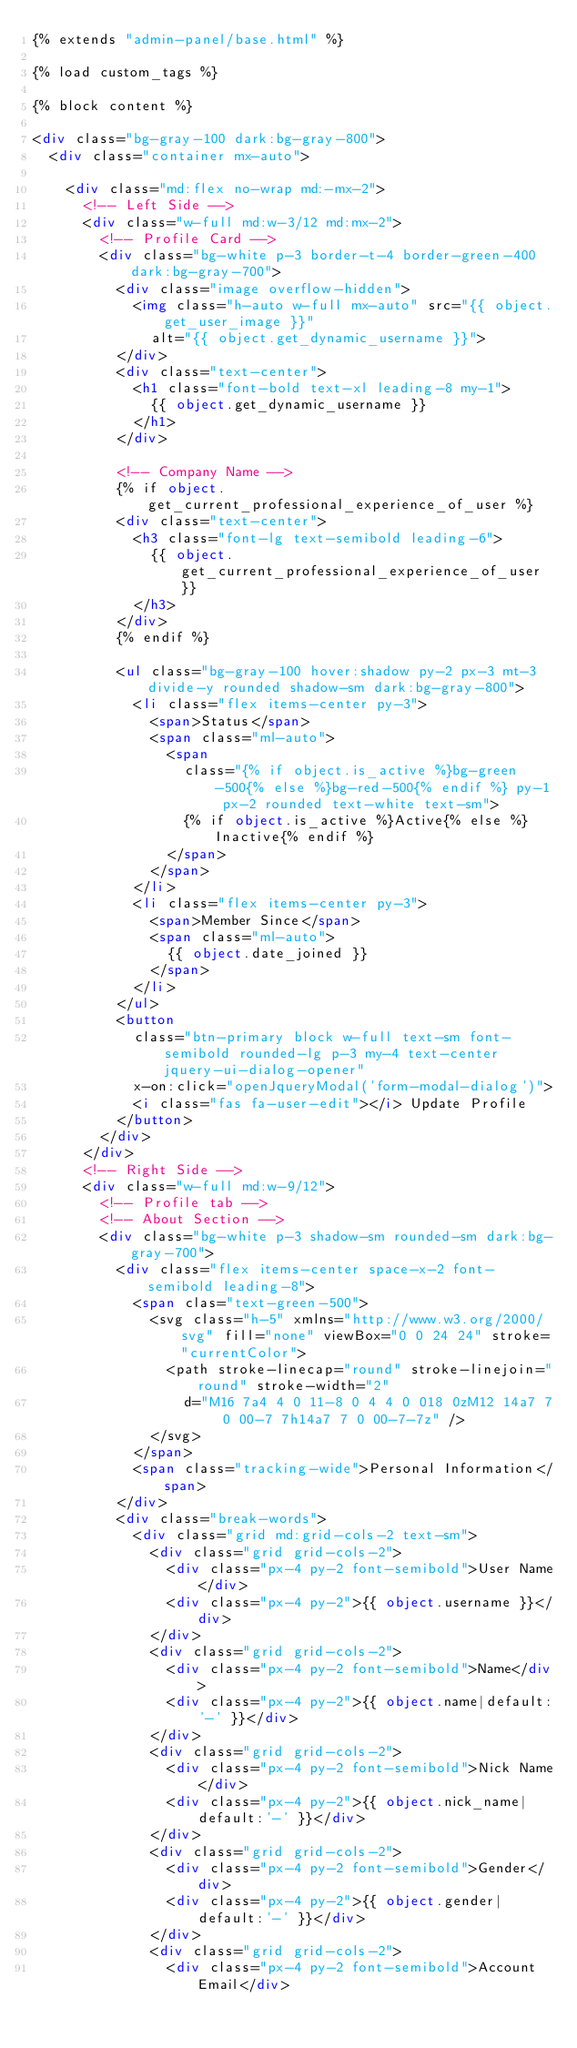Convert code to text. <code><loc_0><loc_0><loc_500><loc_500><_HTML_>{% extends "admin-panel/base.html" %}

{% load custom_tags %}

{% block content %}

<div class="bg-gray-100 dark:bg-gray-800">
  <div class="container mx-auto">

    <div class="md:flex no-wrap md:-mx-2">
      <!-- Left Side -->
      <div class="w-full md:w-3/12 md:mx-2">
        <!-- Profile Card -->
        <div class="bg-white p-3 border-t-4 border-green-400 dark:bg-gray-700">
          <div class="image overflow-hidden">
            <img class="h-auto w-full mx-auto" src="{{ object.get_user_image }}"
              alt="{{ object.get_dynamic_username }}">
          </div>
          <div class="text-center">
            <h1 class="font-bold text-xl leading-8 my-1">
              {{ object.get_dynamic_username }}
            </h1>
          </div>

          <!-- Company Name -->
          {% if object.get_current_professional_experience_of_user %}
          <div class="text-center">
            <h3 class="font-lg text-semibold leading-6">
              {{ object.get_current_professional_experience_of_user }}
            </h3>
          </div>
          {% endif %}

          <ul class="bg-gray-100 hover:shadow py-2 px-3 mt-3 divide-y rounded shadow-sm dark:bg-gray-800">
            <li class="flex items-center py-3">
              <span>Status</span>
              <span class="ml-auto">
                <span
                  class="{% if object.is_active %}bg-green-500{% else %}bg-red-500{% endif %} py-1 px-2 rounded text-white text-sm">
                  {% if object.is_active %}Active{% else %}Inactive{% endif %}
                </span>
              </span>
            </li>
            <li class="flex items-center py-3">
              <span>Member Since</span>
              <span class="ml-auto">
                {{ object.date_joined }}
              </span>
            </li>
          </ul>
          <button
            class="btn-primary block w-full text-sm font-semibold rounded-lg p-3 my-4 text-center jquery-ui-dialog-opener"
            x-on:click="openJqueryModal('form-modal-dialog')">
            <i class="fas fa-user-edit"></i> Update Profile
          </button>
        </div>
      </div>
      <!-- Right Side -->
      <div class="w-full md:w-9/12">
        <!-- Profile tab -->
        <!-- About Section -->
        <div class="bg-white p-3 shadow-sm rounded-sm dark:bg-gray-700">
          <div class="flex items-center space-x-2 font-semibold leading-8">
            <span clas="text-green-500">
              <svg class="h-5" xmlns="http://www.w3.org/2000/svg" fill="none" viewBox="0 0 24 24" stroke="currentColor">
                <path stroke-linecap="round" stroke-linejoin="round" stroke-width="2"
                  d="M16 7a4 4 0 11-8 0 4 4 0 018 0zM12 14a7 7 0 00-7 7h14a7 7 0 00-7-7z" />
              </svg>
            </span>
            <span class="tracking-wide">Personal Information</span>
          </div>
          <div class="break-words">
            <div class="grid md:grid-cols-2 text-sm">
              <div class="grid grid-cols-2">
                <div class="px-4 py-2 font-semibold">User Name</div>
                <div class="px-4 py-2">{{ object.username }}</div>
              </div>
              <div class="grid grid-cols-2">
                <div class="px-4 py-2 font-semibold">Name</div>
                <div class="px-4 py-2">{{ object.name|default:'-' }}</div>
              </div>
              <div class="grid grid-cols-2">
                <div class="px-4 py-2 font-semibold">Nick Name</div>
                <div class="px-4 py-2">{{ object.nick_name|default:'-' }}</div>
              </div>
              <div class="grid grid-cols-2">
                <div class="px-4 py-2 font-semibold">Gender</div>
                <div class="px-4 py-2">{{ object.gender|default:'-' }}</div>
              </div>
              <div class="grid grid-cols-2">
                <div class="px-4 py-2 font-semibold">Account Email</div></code> 